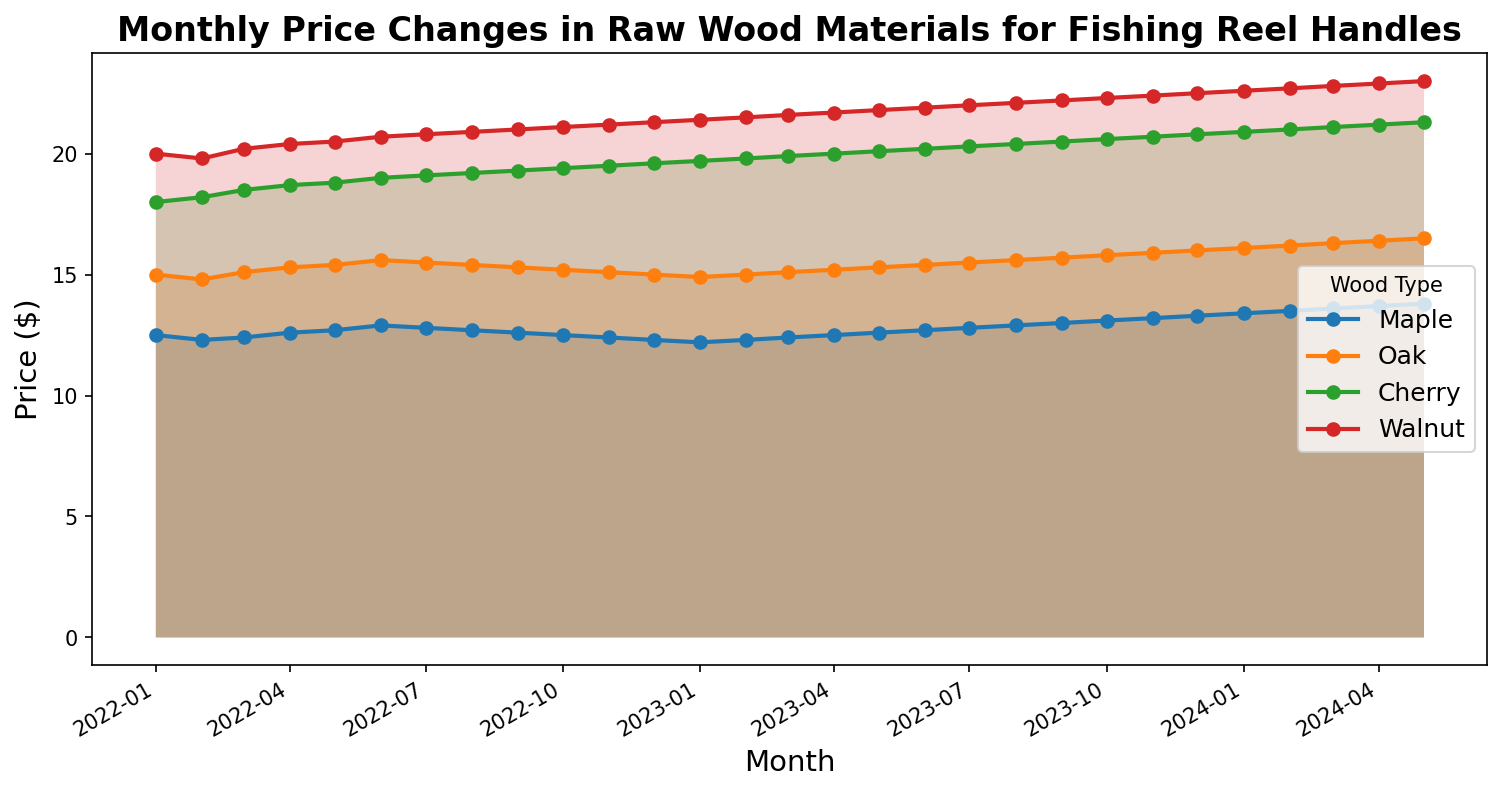Which wood type had the highest price increase from January 2022 to May 2024? To find this, calculate the difference in price from January 2022 to May 2024 for each wood type. Maple: 13.8 - 12.5 = 1.3, Oak: 16.5 - 15.0 = 1.5, Cherry: 21.3 - 18.0 = 3.3, Walnut: 23 - 20 = 3.
Answer: Walnut Which wood type showed the most consistent price trend over the period? The most consistent price trend would be the one with the smoothest line and least fluctuations. By visually inspecting, Maple shows a steady, nearly linear trend compared to others.
Answer: Maple Between Cherry and Walnut, which wood type had a higher price in September 2022? Locate September 2022 on the x-axis, move up to the lines representing Cherry and Walnut, and compare their y-values. Cherry had a price of 19.3, and Walnut had a price of 21.
Answer: Walnut During which month did Maple experience the lowest price? Find the point where the Maple line reaches its lowest on the y-axis. This occurred in January 2023.
Answer: January 2023 Which wood type had the steepest increase in price between two consecutive months? Compare the vertical segments of the lines for each wood type. The steepest increase visually appears for Walnut between December 2022 and January 2023.
Answer: Walnut 